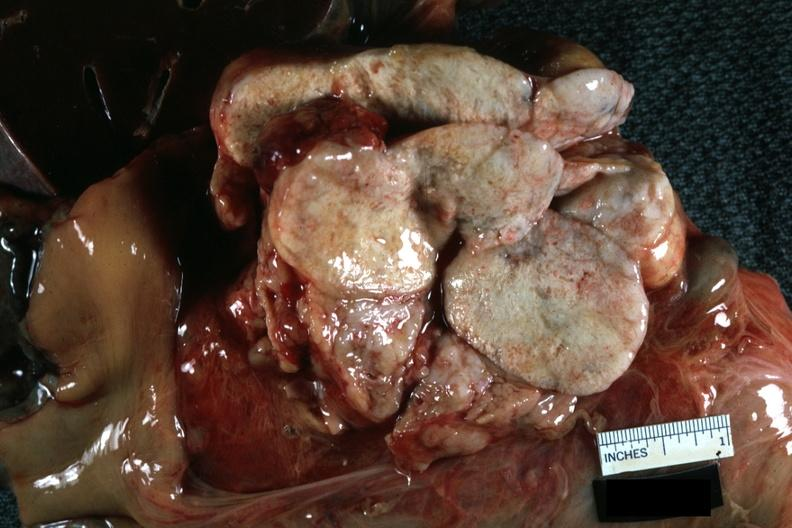how does this image show nodes at tail of pancreas natural color close-up massive replacement?
Answer the question using a single word or phrase. By metastatic lung carcinoma 